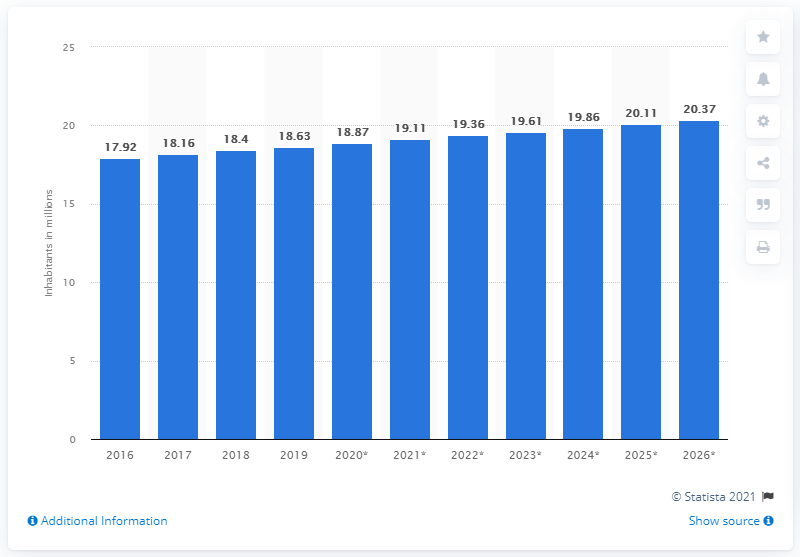Give some essential details in this illustration. In 2019, the population of Kazakhstan was 18.63 million. 